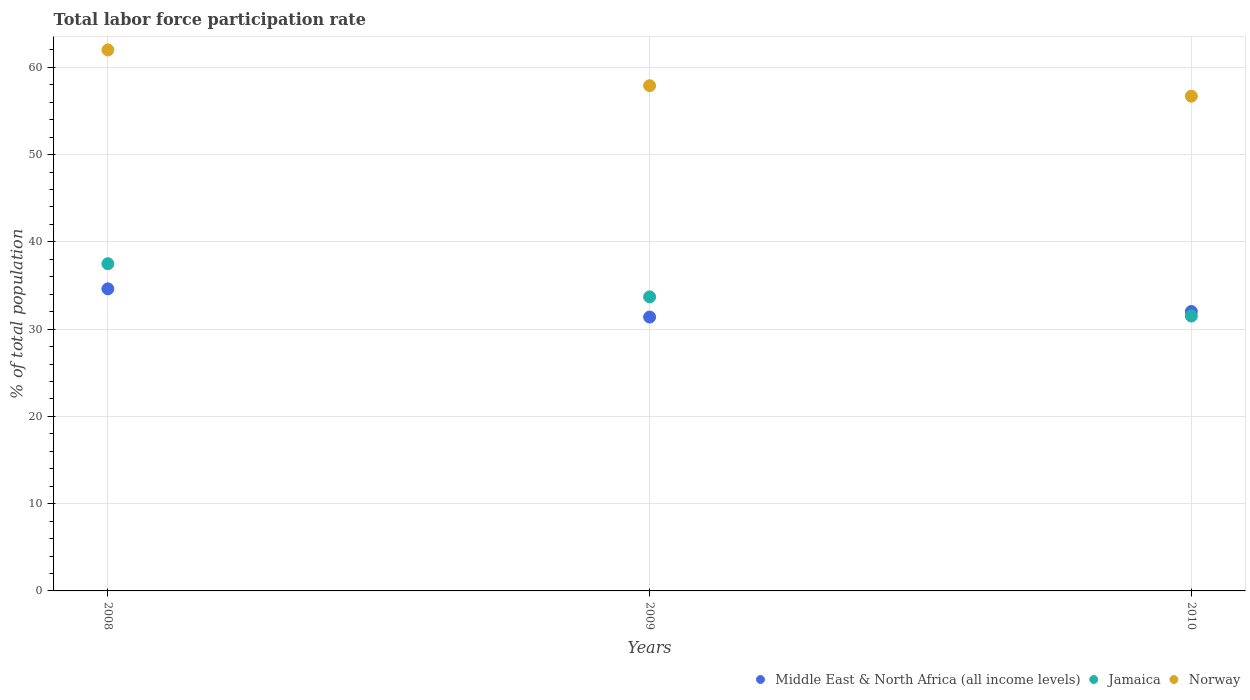How many different coloured dotlines are there?
Offer a terse response. 3. What is the total labor force participation rate in Middle East & North Africa (all income levels) in 2009?
Make the answer very short. 31.39. Across all years, what is the maximum total labor force participation rate in Norway?
Give a very brief answer. 62. Across all years, what is the minimum total labor force participation rate in Jamaica?
Make the answer very short. 31.5. In which year was the total labor force participation rate in Middle East & North Africa (all income levels) maximum?
Make the answer very short. 2008. What is the total total labor force participation rate in Jamaica in the graph?
Your answer should be compact. 102.7. What is the difference between the total labor force participation rate in Norway in 2008 and that in 2010?
Offer a terse response. 5.3. What is the difference between the total labor force participation rate in Norway in 2009 and the total labor force participation rate in Jamaica in 2010?
Offer a terse response. 26.4. What is the average total labor force participation rate in Norway per year?
Keep it short and to the point. 58.87. In the year 2008, what is the difference between the total labor force participation rate in Jamaica and total labor force participation rate in Middle East & North Africa (all income levels)?
Provide a short and direct response. 2.88. What is the ratio of the total labor force participation rate in Norway in 2008 to that in 2010?
Make the answer very short. 1.09. Is the total labor force participation rate in Middle East & North Africa (all income levels) in 2008 less than that in 2010?
Make the answer very short. No. What is the difference between the highest and the second highest total labor force participation rate in Jamaica?
Give a very brief answer. 3.8. In how many years, is the total labor force participation rate in Jamaica greater than the average total labor force participation rate in Jamaica taken over all years?
Provide a short and direct response. 1. Is the sum of the total labor force participation rate in Middle East & North Africa (all income levels) in 2008 and 2010 greater than the maximum total labor force participation rate in Norway across all years?
Offer a terse response. Yes. Is it the case that in every year, the sum of the total labor force participation rate in Middle East & North Africa (all income levels) and total labor force participation rate in Norway  is greater than the total labor force participation rate in Jamaica?
Your answer should be compact. Yes. Is the total labor force participation rate in Norway strictly greater than the total labor force participation rate in Jamaica over the years?
Provide a short and direct response. Yes. Is the total labor force participation rate in Jamaica strictly less than the total labor force participation rate in Middle East & North Africa (all income levels) over the years?
Ensure brevity in your answer.  No. How many years are there in the graph?
Offer a very short reply. 3. Are the values on the major ticks of Y-axis written in scientific E-notation?
Offer a terse response. No. Does the graph contain any zero values?
Make the answer very short. No. How are the legend labels stacked?
Provide a succinct answer. Horizontal. What is the title of the graph?
Ensure brevity in your answer.  Total labor force participation rate. What is the label or title of the Y-axis?
Your answer should be very brief. % of total population. What is the % of total population in Middle East & North Africa (all income levels) in 2008?
Make the answer very short. 34.62. What is the % of total population in Jamaica in 2008?
Offer a terse response. 37.5. What is the % of total population in Norway in 2008?
Give a very brief answer. 62. What is the % of total population in Middle East & North Africa (all income levels) in 2009?
Ensure brevity in your answer.  31.39. What is the % of total population in Jamaica in 2009?
Offer a very short reply. 33.7. What is the % of total population of Norway in 2009?
Your answer should be very brief. 57.9. What is the % of total population of Middle East & North Africa (all income levels) in 2010?
Offer a very short reply. 32.02. What is the % of total population in Jamaica in 2010?
Make the answer very short. 31.5. What is the % of total population in Norway in 2010?
Provide a succinct answer. 56.7. Across all years, what is the maximum % of total population in Middle East & North Africa (all income levels)?
Keep it short and to the point. 34.62. Across all years, what is the maximum % of total population of Jamaica?
Your answer should be very brief. 37.5. Across all years, what is the minimum % of total population in Middle East & North Africa (all income levels)?
Provide a succinct answer. 31.39. Across all years, what is the minimum % of total population of Jamaica?
Provide a short and direct response. 31.5. Across all years, what is the minimum % of total population of Norway?
Ensure brevity in your answer.  56.7. What is the total % of total population of Middle East & North Africa (all income levels) in the graph?
Offer a terse response. 98.03. What is the total % of total population in Jamaica in the graph?
Your answer should be very brief. 102.7. What is the total % of total population in Norway in the graph?
Offer a very short reply. 176.6. What is the difference between the % of total population in Middle East & North Africa (all income levels) in 2008 and that in 2009?
Keep it short and to the point. 3.23. What is the difference between the % of total population of Norway in 2008 and that in 2009?
Provide a short and direct response. 4.1. What is the difference between the % of total population in Middle East & North Africa (all income levels) in 2008 and that in 2010?
Provide a succinct answer. 2.6. What is the difference between the % of total population of Jamaica in 2008 and that in 2010?
Your response must be concise. 6. What is the difference between the % of total population in Norway in 2008 and that in 2010?
Ensure brevity in your answer.  5.3. What is the difference between the % of total population of Middle East & North Africa (all income levels) in 2009 and that in 2010?
Provide a short and direct response. -0.63. What is the difference between the % of total population of Middle East & North Africa (all income levels) in 2008 and the % of total population of Jamaica in 2009?
Give a very brief answer. 0.92. What is the difference between the % of total population of Middle East & North Africa (all income levels) in 2008 and the % of total population of Norway in 2009?
Your response must be concise. -23.28. What is the difference between the % of total population of Jamaica in 2008 and the % of total population of Norway in 2009?
Your answer should be very brief. -20.4. What is the difference between the % of total population of Middle East & North Africa (all income levels) in 2008 and the % of total population of Jamaica in 2010?
Make the answer very short. 3.12. What is the difference between the % of total population of Middle East & North Africa (all income levels) in 2008 and the % of total population of Norway in 2010?
Provide a short and direct response. -22.08. What is the difference between the % of total population of Jamaica in 2008 and the % of total population of Norway in 2010?
Give a very brief answer. -19.2. What is the difference between the % of total population of Middle East & North Africa (all income levels) in 2009 and the % of total population of Jamaica in 2010?
Ensure brevity in your answer.  -0.11. What is the difference between the % of total population of Middle East & North Africa (all income levels) in 2009 and the % of total population of Norway in 2010?
Offer a terse response. -25.31. What is the average % of total population in Middle East & North Africa (all income levels) per year?
Your answer should be very brief. 32.68. What is the average % of total population in Jamaica per year?
Ensure brevity in your answer.  34.23. What is the average % of total population of Norway per year?
Your answer should be compact. 58.87. In the year 2008, what is the difference between the % of total population in Middle East & North Africa (all income levels) and % of total population in Jamaica?
Your response must be concise. -2.88. In the year 2008, what is the difference between the % of total population of Middle East & North Africa (all income levels) and % of total population of Norway?
Keep it short and to the point. -27.38. In the year 2008, what is the difference between the % of total population of Jamaica and % of total population of Norway?
Your response must be concise. -24.5. In the year 2009, what is the difference between the % of total population of Middle East & North Africa (all income levels) and % of total population of Jamaica?
Your response must be concise. -2.31. In the year 2009, what is the difference between the % of total population in Middle East & North Africa (all income levels) and % of total population in Norway?
Your answer should be compact. -26.51. In the year 2009, what is the difference between the % of total population in Jamaica and % of total population in Norway?
Provide a short and direct response. -24.2. In the year 2010, what is the difference between the % of total population in Middle East & North Africa (all income levels) and % of total population in Jamaica?
Give a very brief answer. 0.52. In the year 2010, what is the difference between the % of total population of Middle East & North Africa (all income levels) and % of total population of Norway?
Your answer should be very brief. -24.68. In the year 2010, what is the difference between the % of total population in Jamaica and % of total population in Norway?
Your answer should be compact. -25.2. What is the ratio of the % of total population in Middle East & North Africa (all income levels) in 2008 to that in 2009?
Give a very brief answer. 1.1. What is the ratio of the % of total population of Jamaica in 2008 to that in 2009?
Your response must be concise. 1.11. What is the ratio of the % of total population in Norway in 2008 to that in 2009?
Provide a short and direct response. 1.07. What is the ratio of the % of total population in Middle East & North Africa (all income levels) in 2008 to that in 2010?
Your answer should be compact. 1.08. What is the ratio of the % of total population in Jamaica in 2008 to that in 2010?
Your answer should be very brief. 1.19. What is the ratio of the % of total population in Norway in 2008 to that in 2010?
Offer a very short reply. 1.09. What is the ratio of the % of total population in Middle East & North Africa (all income levels) in 2009 to that in 2010?
Make the answer very short. 0.98. What is the ratio of the % of total population in Jamaica in 2009 to that in 2010?
Your answer should be very brief. 1.07. What is the ratio of the % of total population in Norway in 2009 to that in 2010?
Offer a terse response. 1.02. What is the difference between the highest and the second highest % of total population in Middle East & North Africa (all income levels)?
Your answer should be compact. 2.6. What is the difference between the highest and the second highest % of total population in Norway?
Your response must be concise. 4.1. What is the difference between the highest and the lowest % of total population of Middle East & North Africa (all income levels)?
Your answer should be very brief. 3.23. What is the difference between the highest and the lowest % of total population of Norway?
Make the answer very short. 5.3. 